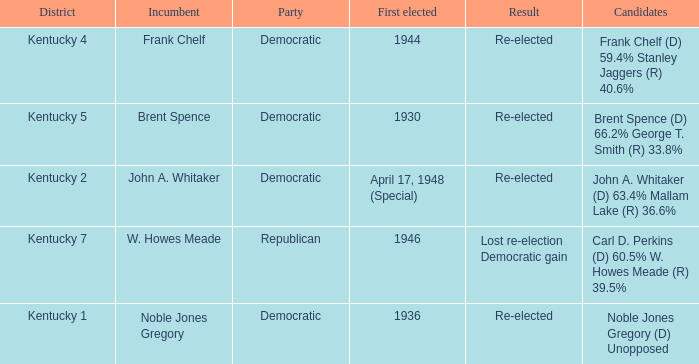List all candidates in the democratic party where the election had the incumbent Frank Chelf running. Frank Chelf (D) 59.4% Stanley Jaggers (R) 40.6%. 